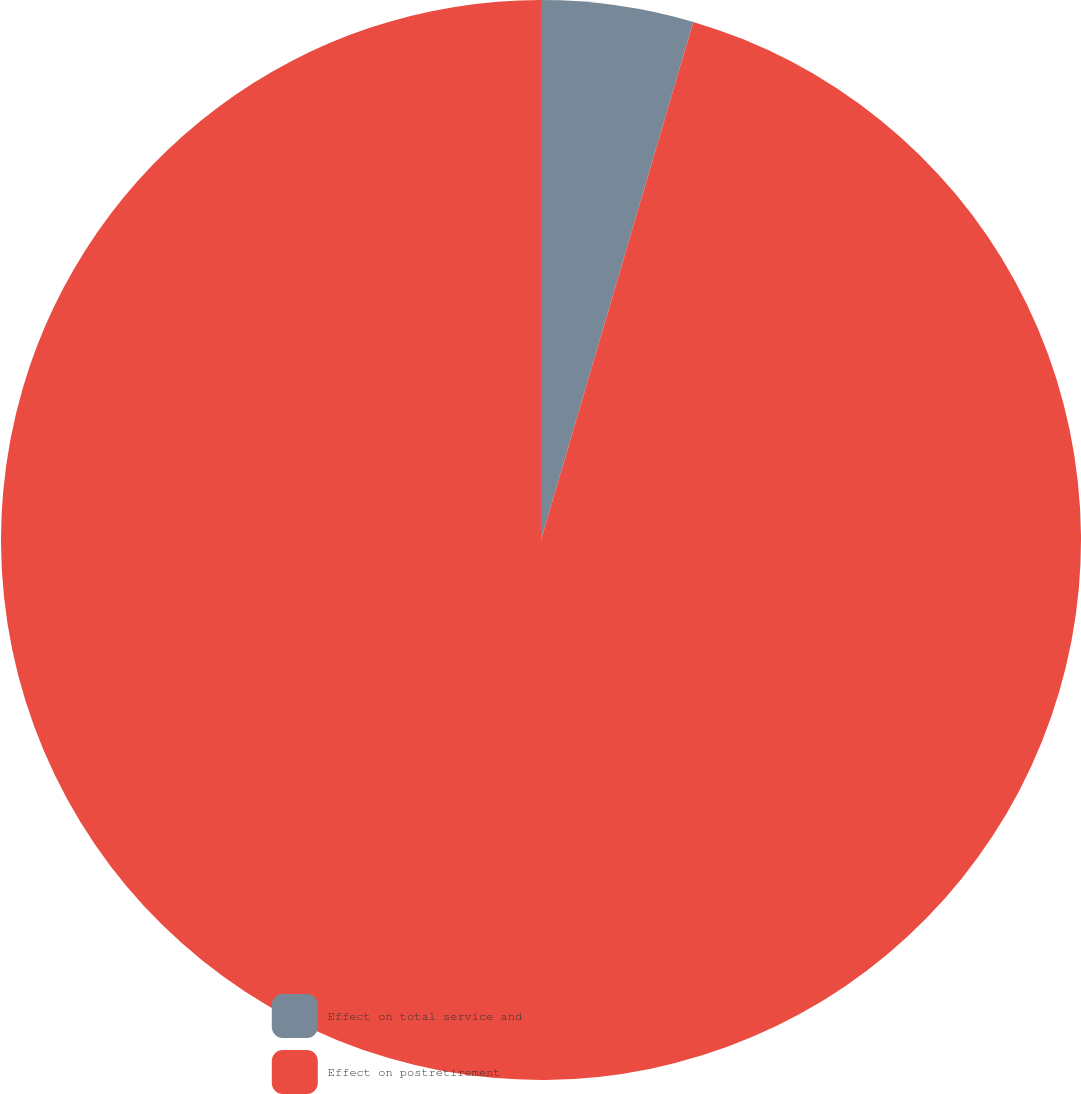<chart> <loc_0><loc_0><loc_500><loc_500><pie_chart><fcel>Effect on total service and<fcel>Effect on postretirement<nl><fcel>4.55%<fcel>95.45%<nl></chart> 